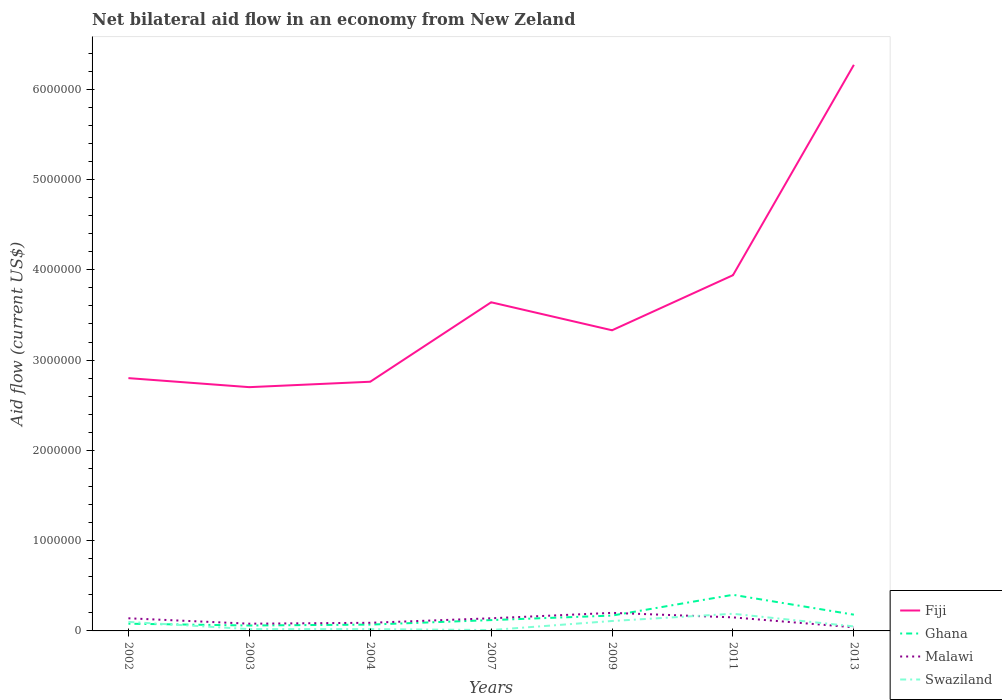Does the line corresponding to Fiji intersect with the line corresponding to Malawi?
Keep it short and to the point. No. Is the number of lines equal to the number of legend labels?
Make the answer very short. Yes. What is the total net bilateral aid flow in Malawi in the graph?
Provide a short and direct response. 0. What is the difference between the highest and the second highest net bilateral aid flow in Swaziland?
Ensure brevity in your answer.  1.80e+05. What is the difference between the highest and the lowest net bilateral aid flow in Swaziland?
Make the answer very short. 3. What is the difference between two consecutive major ticks on the Y-axis?
Give a very brief answer. 1.00e+06. Does the graph contain any zero values?
Your answer should be very brief. No. How many legend labels are there?
Provide a short and direct response. 4. How are the legend labels stacked?
Ensure brevity in your answer.  Vertical. What is the title of the graph?
Your answer should be compact. Net bilateral aid flow in an economy from New Zeland. Does "Caribbean small states" appear as one of the legend labels in the graph?
Provide a short and direct response. No. What is the label or title of the Y-axis?
Give a very brief answer. Aid flow (current US$). What is the Aid flow (current US$) in Fiji in 2002?
Provide a short and direct response. 2.80e+06. What is the Aid flow (current US$) in Ghana in 2002?
Your answer should be very brief. 8.00e+04. What is the Aid flow (current US$) in Malawi in 2002?
Give a very brief answer. 1.40e+05. What is the Aid flow (current US$) of Swaziland in 2002?
Give a very brief answer. 1.00e+05. What is the Aid flow (current US$) in Fiji in 2003?
Provide a succinct answer. 2.70e+06. What is the Aid flow (current US$) of Malawi in 2003?
Your response must be concise. 8.00e+04. What is the Aid flow (current US$) in Swaziland in 2003?
Give a very brief answer. 2.00e+04. What is the Aid flow (current US$) in Fiji in 2004?
Offer a very short reply. 2.76e+06. What is the Aid flow (current US$) in Ghana in 2004?
Keep it short and to the point. 7.00e+04. What is the Aid flow (current US$) of Fiji in 2007?
Your answer should be compact. 3.64e+06. What is the Aid flow (current US$) of Ghana in 2007?
Your answer should be compact. 1.20e+05. What is the Aid flow (current US$) in Malawi in 2007?
Offer a terse response. 1.40e+05. What is the Aid flow (current US$) in Fiji in 2009?
Ensure brevity in your answer.  3.33e+06. What is the Aid flow (current US$) of Swaziland in 2009?
Ensure brevity in your answer.  1.10e+05. What is the Aid flow (current US$) in Fiji in 2011?
Give a very brief answer. 3.94e+06. What is the Aid flow (current US$) of Swaziland in 2011?
Offer a terse response. 1.90e+05. What is the Aid flow (current US$) in Fiji in 2013?
Offer a terse response. 6.27e+06. What is the Aid flow (current US$) in Malawi in 2013?
Your response must be concise. 4.00e+04. What is the Aid flow (current US$) of Swaziland in 2013?
Make the answer very short. 5.00e+04. Across all years, what is the maximum Aid flow (current US$) of Fiji?
Provide a succinct answer. 6.27e+06. Across all years, what is the maximum Aid flow (current US$) in Ghana?
Give a very brief answer. 4.00e+05. Across all years, what is the maximum Aid flow (current US$) in Malawi?
Offer a very short reply. 2.00e+05. Across all years, what is the maximum Aid flow (current US$) of Swaziland?
Make the answer very short. 1.90e+05. Across all years, what is the minimum Aid flow (current US$) in Fiji?
Make the answer very short. 2.70e+06. Across all years, what is the minimum Aid flow (current US$) of Malawi?
Provide a short and direct response. 4.00e+04. Across all years, what is the minimum Aid flow (current US$) in Swaziland?
Your answer should be compact. 10000. What is the total Aid flow (current US$) in Fiji in the graph?
Provide a short and direct response. 2.54e+07. What is the total Aid flow (current US$) of Ghana in the graph?
Keep it short and to the point. 1.08e+06. What is the total Aid flow (current US$) of Malawi in the graph?
Ensure brevity in your answer.  8.40e+05. What is the difference between the Aid flow (current US$) of Fiji in 2002 and that in 2003?
Ensure brevity in your answer.  1.00e+05. What is the difference between the Aid flow (current US$) of Malawi in 2002 and that in 2003?
Give a very brief answer. 6.00e+04. What is the difference between the Aid flow (current US$) in Fiji in 2002 and that in 2004?
Keep it short and to the point. 4.00e+04. What is the difference between the Aid flow (current US$) in Ghana in 2002 and that in 2004?
Keep it short and to the point. 10000. What is the difference between the Aid flow (current US$) of Swaziland in 2002 and that in 2004?
Provide a short and direct response. 8.00e+04. What is the difference between the Aid flow (current US$) in Fiji in 2002 and that in 2007?
Give a very brief answer. -8.40e+05. What is the difference between the Aid flow (current US$) in Malawi in 2002 and that in 2007?
Ensure brevity in your answer.  0. What is the difference between the Aid flow (current US$) of Fiji in 2002 and that in 2009?
Provide a short and direct response. -5.30e+05. What is the difference between the Aid flow (current US$) in Ghana in 2002 and that in 2009?
Provide a short and direct response. -9.00e+04. What is the difference between the Aid flow (current US$) in Malawi in 2002 and that in 2009?
Provide a succinct answer. -6.00e+04. What is the difference between the Aid flow (current US$) of Swaziland in 2002 and that in 2009?
Offer a terse response. -10000. What is the difference between the Aid flow (current US$) of Fiji in 2002 and that in 2011?
Offer a terse response. -1.14e+06. What is the difference between the Aid flow (current US$) of Ghana in 2002 and that in 2011?
Give a very brief answer. -3.20e+05. What is the difference between the Aid flow (current US$) of Malawi in 2002 and that in 2011?
Your response must be concise. -10000. What is the difference between the Aid flow (current US$) in Swaziland in 2002 and that in 2011?
Your answer should be compact. -9.00e+04. What is the difference between the Aid flow (current US$) in Fiji in 2002 and that in 2013?
Your response must be concise. -3.47e+06. What is the difference between the Aid flow (current US$) of Malawi in 2002 and that in 2013?
Provide a short and direct response. 1.00e+05. What is the difference between the Aid flow (current US$) of Swaziland in 2002 and that in 2013?
Your response must be concise. 5.00e+04. What is the difference between the Aid flow (current US$) of Ghana in 2003 and that in 2004?
Give a very brief answer. -10000. What is the difference between the Aid flow (current US$) in Malawi in 2003 and that in 2004?
Offer a terse response. -10000. What is the difference between the Aid flow (current US$) of Fiji in 2003 and that in 2007?
Give a very brief answer. -9.40e+05. What is the difference between the Aid flow (current US$) in Malawi in 2003 and that in 2007?
Make the answer very short. -6.00e+04. What is the difference between the Aid flow (current US$) of Fiji in 2003 and that in 2009?
Your response must be concise. -6.30e+05. What is the difference between the Aid flow (current US$) of Malawi in 2003 and that in 2009?
Your answer should be very brief. -1.20e+05. What is the difference between the Aid flow (current US$) of Fiji in 2003 and that in 2011?
Offer a terse response. -1.24e+06. What is the difference between the Aid flow (current US$) of Swaziland in 2003 and that in 2011?
Provide a short and direct response. -1.70e+05. What is the difference between the Aid flow (current US$) of Fiji in 2003 and that in 2013?
Your answer should be compact. -3.57e+06. What is the difference between the Aid flow (current US$) in Fiji in 2004 and that in 2007?
Offer a very short reply. -8.80e+05. What is the difference between the Aid flow (current US$) of Ghana in 2004 and that in 2007?
Provide a short and direct response. -5.00e+04. What is the difference between the Aid flow (current US$) of Malawi in 2004 and that in 2007?
Make the answer very short. -5.00e+04. What is the difference between the Aid flow (current US$) in Swaziland in 2004 and that in 2007?
Make the answer very short. 10000. What is the difference between the Aid flow (current US$) of Fiji in 2004 and that in 2009?
Your answer should be very brief. -5.70e+05. What is the difference between the Aid flow (current US$) in Ghana in 2004 and that in 2009?
Offer a terse response. -1.00e+05. What is the difference between the Aid flow (current US$) of Swaziland in 2004 and that in 2009?
Offer a terse response. -9.00e+04. What is the difference between the Aid flow (current US$) in Fiji in 2004 and that in 2011?
Provide a succinct answer. -1.18e+06. What is the difference between the Aid flow (current US$) in Ghana in 2004 and that in 2011?
Provide a short and direct response. -3.30e+05. What is the difference between the Aid flow (current US$) of Swaziland in 2004 and that in 2011?
Provide a succinct answer. -1.70e+05. What is the difference between the Aid flow (current US$) of Fiji in 2004 and that in 2013?
Offer a terse response. -3.51e+06. What is the difference between the Aid flow (current US$) of Ghana in 2004 and that in 2013?
Provide a succinct answer. -1.10e+05. What is the difference between the Aid flow (current US$) of Fiji in 2007 and that in 2009?
Make the answer very short. 3.10e+05. What is the difference between the Aid flow (current US$) in Malawi in 2007 and that in 2009?
Your answer should be compact. -6.00e+04. What is the difference between the Aid flow (current US$) in Fiji in 2007 and that in 2011?
Make the answer very short. -3.00e+05. What is the difference between the Aid flow (current US$) in Ghana in 2007 and that in 2011?
Offer a terse response. -2.80e+05. What is the difference between the Aid flow (current US$) of Fiji in 2007 and that in 2013?
Your answer should be compact. -2.63e+06. What is the difference between the Aid flow (current US$) in Swaziland in 2007 and that in 2013?
Provide a short and direct response. -4.00e+04. What is the difference between the Aid flow (current US$) of Fiji in 2009 and that in 2011?
Offer a very short reply. -6.10e+05. What is the difference between the Aid flow (current US$) in Malawi in 2009 and that in 2011?
Ensure brevity in your answer.  5.00e+04. What is the difference between the Aid flow (current US$) in Swaziland in 2009 and that in 2011?
Your response must be concise. -8.00e+04. What is the difference between the Aid flow (current US$) of Fiji in 2009 and that in 2013?
Keep it short and to the point. -2.94e+06. What is the difference between the Aid flow (current US$) of Fiji in 2011 and that in 2013?
Give a very brief answer. -2.33e+06. What is the difference between the Aid flow (current US$) of Malawi in 2011 and that in 2013?
Your response must be concise. 1.10e+05. What is the difference between the Aid flow (current US$) of Swaziland in 2011 and that in 2013?
Your response must be concise. 1.40e+05. What is the difference between the Aid flow (current US$) of Fiji in 2002 and the Aid flow (current US$) of Ghana in 2003?
Ensure brevity in your answer.  2.74e+06. What is the difference between the Aid flow (current US$) in Fiji in 2002 and the Aid flow (current US$) in Malawi in 2003?
Provide a short and direct response. 2.72e+06. What is the difference between the Aid flow (current US$) in Fiji in 2002 and the Aid flow (current US$) in Swaziland in 2003?
Provide a succinct answer. 2.78e+06. What is the difference between the Aid flow (current US$) in Ghana in 2002 and the Aid flow (current US$) in Swaziland in 2003?
Keep it short and to the point. 6.00e+04. What is the difference between the Aid flow (current US$) in Malawi in 2002 and the Aid flow (current US$) in Swaziland in 2003?
Your response must be concise. 1.20e+05. What is the difference between the Aid flow (current US$) of Fiji in 2002 and the Aid flow (current US$) of Ghana in 2004?
Give a very brief answer. 2.73e+06. What is the difference between the Aid flow (current US$) of Fiji in 2002 and the Aid flow (current US$) of Malawi in 2004?
Offer a terse response. 2.71e+06. What is the difference between the Aid flow (current US$) in Fiji in 2002 and the Aid flow (current US$) in Swaziland in 2004?
Give a very brief answer. 2.78e+06. What is the difference between the Aid flow (current US$) in Ghana in 2002 and the Aid flow (current US$) in Malawi in 2004?
Your answer should be compact. -10000. What is the difference between the Aid flow (current US$) of Ghana in 2002 and the Aid flow (current US$) of Swaziland in 2004?
Offer a terse response. 6.00e+04. What is the difference between the Aid flow (current US$) in Malawi in 2002 and the Aid flow (current US$) in Swaziland in 2004?
Offer a very short reply. 1.20e+05. What is the difference between the Aid flow (current US$) in Fiji in 2002 and the Aid flow (current US$) in Ghana in 2007?
Offer a very short reply. 2.68e+06. What is the difference between the Aid flow (current US$) of Fiji in 2002 and the Aid flow (current US$) of Malawi in 2007?
Offer a terse response. 2.66e+06. What is the difference between the Aid flow (current US$) in Fiji in 2002 and the Aid flow (current US$) in Swaziland in 2007?
Provide a succinct answer. 2.79e+06. What is the difference between the Aid flow (current US$) of Ghana in 2002 and the Aid flow (current US$) of Malawi in 2007?
Your response must be concise. -6.00e+04. What is the difference between the Aid flow (current US$) in Fiji in 2002 and the Aid flow (current US$) in Ghana in 2009?
Keep it short and to the point. 2.63e+06. What is the difference between the Aid flow (current US$) of Fiji in 2002 and the Aid flow (current US$) of Malawi in 2009?
Give a very brief answer. 2.60e+06. What is the difference between the Aid flow (current US$) in Fiji in 2002 and the Aid flow (current US$) in Swaziland in 2009?
Offer a terse response. 2.69e+06. What is the difference between the Aid flow (current US$) of Fiji in 2002 and the Aid flow (current US$) of Ghana in 2011?
Your answer should be compact. 2.40e+06. What is the difference between the Aid flow (current US$) in Fiji in 2002 and the Aid flow (current US$) in Malawi in 2011?
Offer a very short reply. 2.65e+06. What is the difference between the Aid flow (current US$) of Fiji in 2002 and the Aid flow (current US$) of Swaziland in 2011?
Offer a terse response. 2.61e+06. What is the difference between the Aid flow (current US$) of Fiji in 2002 and the Aid flow (current US$) of Ghana in 2013?
Ensure brevity in your answer.  2.62e+06. What is the difference between the Aid flow (current US$) in Fiji in 2002 and the Aid flow (current US$) in Malawi in 2013?
Offer a terse response. 2.76e+06. What is the difference between the Aid flow (current US$) of Fiji in 2002 and the Aid flow (current US$) of Swaziland in 2013?
Ensure brevity in your answer.  2.75e+06. What is the difference between the Aid flow (current US$) of Ghana in 2002 and the Aid flow (current US$) of Malawi in 2013?
Your answer should be compact. 4.00e+04. What is the difference between the Aid flow (current US$) of Fiji in 2003 and the Aid flow (current US$) of Ghana in 2004?
Your answer should be very brief. 2.63e+06. What is the difference between the Aid flow (current US$) of Fiji in 2003 and the Aid flow (current US$) of Malawi in 2004?
Make the answer very short. 2.61e+06. What is the difference between the Aid flow (current US$) of Fiji in 2003 and the Aid flow (current US$) of Swaziland in 2004?
Give a very brief answer. 2.68e+06. What is the difference between the Aid flow (current US$) of Ghana in 2003 and the Aid flow (current US$) of Malawi in 2004?
Give a very brief answer. -3.00e+04. What is the difference between the Aid flow (current US$) in Malawi in 2003 and the Aid flow (current US$) in Swaziland in 2004?
Your answer should be very brief. 6.00e+04. What is the difference between the Aid flow (current US$) in Fiji in 2003 and the Aid flow (current US$) in Ghana in 2007?
Provide a short and direct response. 2.58e+06. What is the difference between the Aid flow (current US$) in Fiji in 2003 and the Aid flow (current US$) in Malawi in 2007?
Make the answer very short. 2.56e+06. What is the difference between the Aid flow (current US$) of Fiji in 2003 and the Aid flow (current US$) of Swaziland in 2007?
Keep it short and to the point. 2.69e+06. What is the difference between the Aid flow (current US$) in Ghana in 2003 and the Aid flow (current US$) in Malawi in 2007?
Your answer should be very brief. -8.00e+04. What is the difference between the Aid flow (current US$) of Ghana in 2003 and the Aid flow (current US$) of Swaziland in 2007?
Your answer should be compact. 5.00e+04. What is the difference between the Aid flow (current US$) in Fiji in 2003 and the Aid flow (current US$) in Ghana in 2009?
Provide a succinct answer. 2.53e+06. What is the difference between the Aid flow (current US$) of Fiji in 2003 and the Aid flow (current US$) of Malawi in 2009?
Offer a very short reply. 2.50e+06. What is the difference between the Aid flow (current US$) in Fiji in 2003 and the Aid flow (current US$) in Swaziland in 2009?
Offer a terse response. 2.59e+06. What is the difference between the Aid flow (current US$) in Ghana in 2003 and the Aid flow (current US$) in Malawi in 2009?
Make the answer very short. -1.40e+05. What is the difference between the Aid flow (current US$) in Ghana in 2003 and the Aid flow (current US$) in Swaziland in 2009?
Give a very brief answer. -5.00e+04. What is the difference between the Aid flow (current US$) in Malawi in 2003 and the Aid flow (current US$) in Swaziland in 2009?
Give a very brief answer. -3.00e+04. What is the difference between the Aid flow (current US$) in Fiji in 2003 and the Aid flow (current US$) in Ghana in 2011?
Your response must be concise. 2.30e+06. What is the difference between the Aid flow (current US$) of Fiji in 2003 and the Aid flow (current US$) of Malawi in 2011?
Provide a succinct answer. 2.55e+06. What is the difference between the Aid flow (current US$) in Fiji in 2003 and the Aid flow (current US$) in Swaziland in 2011?
Ensure brevity in your answer.  2.51e+06. What is the difference between the Aid flow (current US$) in Ghana in 2003 and the Aid flow (current US$) in Malawi in 2011?
Give a very brief answer. -9.00e+04. What is the difference between the Aid flow (current US$) of Fiji in 2003 and the Aid flow (current US$) of Ghana in 2013?
Give a very brief answer. 2.52e+06. What is the difference between the Aid flow (current US$) in Fiji in 2003 and the Aid flow (current US$) in Malawi in 2013?
Ensure brevity in your answer.  2.66e+06. What is the difference between the Aid flow (current US$) in Fiji in 2003 and the Aid flow (current US$) in Swaziland in 2013?
Your answer should be very brief. 2.65e+06. What is the difference between the Aid flow (current US$) of Malawi in 2003 and the Aid flow (current US$) of Swaziland in 2013?
Provide a short and direct response. 3.00e+04. What is the difference between the Aid flow (current US$) of Fiji in 2004 and the Aid flow (current US$) of Ghana in 2007?
Your answer should be compact. 2.64e+06. What is the difference between the Aid flow (current US$) in Fiji in 2004 and the Aid flow (current US$) in Malawi in 2007?
Provide a short and direct response. 2.62e+06. What is the difference between the Aid flow (current US$) of Fiji in 2004 and the Aid flow (current US$) of Swaziland in 2007?
Your answer should be very brief. 2.75e+06. What is the difference between the Aid flow (current US$) in Ghana in 2004 and the Aid flow (current US$) in Swaziland in 2007?
Give a very brief answer. 6.00e+04. What is the difference between the Aid flow (current US$) in Fiji in 2004 and the Aid flow (current US$) in Ghana in 2009?
Keep it short and to the point. 2.59e+06. What is the difference between the Aid flow (current US$) of Fiji in 2004 and the Aid flow (current US$) of Malawi in 2009?
Your answer should be very brief. 2.56e+06. What is the difference between the Aid flow (current US$) in Fiji in 2004 and the Aid flow (current US$) in Swaziland in 2009?
Keep it short and to the point. 2.65e+06. What is the difference between the Aid flow (current US$) in Ghana in 2004 and the Aid flow (current US$) in Swaziland in 2009?
Ensure brevity in your answer.  -4.00e+04. What is the difference between the Aid flow (current US$) in Malawi in 2004 and the Aid flow (current US$) in Swaziland in 2009?
Your response must be concise. -2.00e+04. What is the difference between the Aid flow (current US$) of Fiji in 2004 and the Aid flow (current US$) of Ghana in 2011?
Keep it short and to the point. 2.36e+06. What is the difference between the Aid flow (current US$) in Fiji in 2004 and the Aid flow (current US$) in Malawi in 2011?
Make the answer very short. 2.61e+06. What is the difference between the Aid flow (current US$) of Fiji in 2004 and the Aid flow (current US$) of Swaziland in 2011?
Provide a short and direct response. 2.57e+06. What is the difference between the Aid flow (current US$) of Ghana in 2004 and the Aid flow (current US$) of Malawi in 2011?
Provide a succinct answer. -8.00e+04. What is the difference between the Aid flow (current US$) of Fiji in 2004 and the Aid flow (current US$) of Ghana in 2013?
Provide a short and direct response. 2.58e+06. What is the difference between the Aid flow (current US$) of Fiji in 2004 and the Aid flow (current US$) of Malawi in 2013?
Your answer should be very brief. 2.72e+06. What is the difference between the Aid flow (current US$) in Fiji in 2004 and the Aid flow (current US$) in Swaziland in 2013?
Your answer should be compact. 2.71e+06. What is the difference between the Aid flow (current US$) in Ghana in 2004 and the Aid flow (current US$) in Swaziland in 2013?
Ensure brevity in your answer.  2.00e+04. What is the difference between the Aid flow (current US$) in Fiji in 2007 and the Aid flow (current US$) in Ghana in 2009?
Provide a short and direct response. 3.47e+06. What is the difference between the Aid flow (current US$) of Fiji in 2007 and the Aid flow (current US$) of Malawi in 2009?
Provide a short and direct response. 3.44e+06. What is the difference between the Aid flow (current US$) in Fiji in 2007 and the Aid flow (current US$) in Swaziland in 2009?
Your answer should be compact. 3.53e+06. What is the difference between the Aid flow (current US$) of Ghana in 2007 and the Aid flow (current US$) of Swaziland in 2009?
Your response must be concise. 10000. What is the difference between the Aid flow (current US$) of Fiji in 2007 and the Aid flow (current US$) of Ghana in 2011?
Your response must be concise. 3.24e+06. What is the difference between the Aid flow (current US$) of Fiji in 2007 and the Aid flow (current US$) of Malawi in 2011?
Make the answer very short. 3.49e+06. What is the difference between the Aid flow (current US$) of Fiji in 2007 and the Aid flow (current US$) of Swaziland in 2011?
Make the answer very short. 3.45e+06. What is the difference between the Aid flow (current US$) in Ghana in 2007 and the Aid flow (current US$) in Malawi in 2011?
Keep it short and to the point. -3.00e+04. What is the difference between the Aid flow (current US$) of Fiji in 2007 and the Aid flow (current US$) of Ghana in 2013?
Ensure brevity in your answer.  3.46e+06. What is the difference between the Aid flow (current US$) in Fiji in 2007 and the Aid flow (current US$) in Malawi in 2013?
Your response must be concise. 3.60e+06. What is the difference between the Aid flow (current US$) in Fiji in 2007 and the Aid flow (current US$) in Swaziland in 2013?
Offer a very short reply. 3.59e+06. What is the difference between the Aid flow (current US$) in Malawi in 2007 and the Aid flow (current US$) in Swaziland in 2013?
Your response must be concise. 9.00e+04. What is the difference between the Aid flow (current US$) of Fiji in 2009 and the Aid flow (current US$) of Ghana in 2011?
Your answer should be very brief. 2.93e+06. What is the difference between the Aid flow (current US$) in Fiji in 2009 and the Aid flow (current US$) in Malawi in 2011?
Your response must be concise. 3.18e+06. What is the difference between the Aid flow (current US$) in Fiji in 2009 and the Aid flow (current US$) in Swaziland in 2011?
Your answer should be compact. 3.14e+06. What is the difference between the Aid flow (current US$) of Malawi in 2009 and the Aid flow (current US$) of Swaziland in 2011?
Offer a terse response. 10000. What is the difference between the Aid flow (current US$) of Fiji in 2009 and the Aid flow (current US$) of Ghana in 2013?
Your response must be concise. 3.15e+06. What is the difference between the Aid flow (current US$) of Fiji in 2009 and the Aid flow (current US$) of Malawi in 2013?
Your response must be concise. 3.29e+06. What is the difference between the Aid flow (current US$) in Fiji in 2009 and the Aid flow (current US$) in Swaziland in 2013?
Provide a succinct answer. 3.28e+06. What is the difference between the Aid flow (current US$) of Ghana in 2009 and the Aid flow (current US$) of Malawi in 2013?
Your answer should be compact. 1.30e+05. What is the difference between the Aid flow (current US$) in Ghana in 2009 and the Aid flow (current US$) in Swaziland in 2013?
Provide a short and direct response. 1.20e+05. What is the difference between the Aid flow (current US$) of Fiji in 2011 and the Aid flow (current US$) of Ghana in 2013?
Ensure brevity in your answer.  3.76e+06. What is the difference between the Aid flow (current US$) in Fiji in 2011 and the Aid flow (current US$) in Malawi in 2013?
Ensure brevity in your answer.  3.90e+06. What is the difference between the Aid flow (current US$) of Fiji in 2011 and the Aid flow (current US$) of Swaziland in 2013?
Provide a short and direct response. 3.89e+06. What is the difference between the Aid flow (current US$) in Ghana in 2011 and the Aid flow (current US$) in Malawi in 2013?
Offer a terse response. 3.60e+05. What is the difference between the Aid flow (current US$) in Ghana in 2011 and the Aid flow (current US$) in Swaziland in 2013?
Provide a short and direct response. 3.50e+05. What is the average Aid flow (current US$) in Fiji per year?
Your response must be concise. 3.63e+06. What is the average Aid flow (current US$) of Ghana per year?
Make the answer very short. 1.54e+05. What is the average Aid flow (current US$) of Swaziland per year?
Your answer should be compact. 7.14e+04. In the year 2002, what is the difference between the Aid flow (current US$) of Fiji and Aid flow (current US$) of Ghana?
Your answer should be compact. 2.72e+06. In the year 2002, what is the difference between the Aid flow (current US$) in Fiji and Aid flow (current US$) in Malawi?
Provide a short and direct response. 2.66e+06. In the year 2002, what is the difference between the Aid flow (current US$) of Fiji and Aid flow (current US$) of Swaziland?
Provide a short and direct response. 2.70e+06. In the year 2002, what is the difference between the Aid flow (current US$) in Ghana and Aid flow (current US$) in Swaziland?
Your response must be concise. -2.00e+04. In the year 2003, what is the difference between the Aid flow (current US$) in Fiji and Aid flow (current US$) in Ghana?
Your answer should be very brief. 2.64e+06. In the year 2003, what is the difference between the Aid flow (current US$) in Fiji and Aid flow (current US$) in Malawi?
Provide a short and direct response. 2.62e+06. In the year 2003, what is the difference between the Aid flow (current US$) of Fiji and Aid flow (current US$) of Swaziland?
Offer a terse response. 2.68e+06. In the year 2003, what is the difference between the Aid flow (current US$) in Ghana and Aid flow (current US$) in Malawi?
Provide a succinct answer. -2.00e+04. In the year 2003, what is the difference between the Aid flow (current US$) in Ghana and Aid flow (current US$) in Swaziland?
Make the answer very short. 4.00e+04. In the year 2003, what is the difference between the Aid flow (current US$) in Malawi and Aid flow (current US$) in Swaziland?
Your response must be concise. 6.00e+04. In the year 2004, what is the difference between the Aid flow (current US$) in Fiji and Aid flow (current US$) in Ghana?
Your answer should be compact. 2.69e+06. In the year 2004, what is the difference between the Aid flow (current US$) in Fiji and Aid flow (current US$) in Malawi?
Make the answer very short. 2.67e+06. In the year 2004, what is the difference between the Aid flow (current US$) of Fiji and Aid flow (current US$) of Swaziland?
Make the answer very short. 2.74e+06. In the year 2004, what is the difference between the Aid flow (current US$) of Malawi and Aid flow (current US$) of Swaziland?
Your answer should be very brief. 7.00e+04. In the year 2007, what is the difference between the Aid flow (current US$) of Fiji and Aid flow (current US$) of Ghana?
Your answer should be very brief. 3.52e+06. In the year 2007, what is the difference between the Aid flow (current US$) in Fiji and Aid flow (current US$) in Malawi?
Keep it short and to the point. 3.50e+06. In the year 2007, what is the difference between the Aid flow (current US$) of Fiji and Aid flow (current US$) of Swaziland?
Make the answer very short. 3.63e+06. In the year 2007, what is the difference between the Aid flow (current US$) in Ghana and Aid flow (current US$) in Swaziland?
Ensure brevity in your answer.  1.10e+05. In the year 2009, what is the difference between the Aid flow (current US$) of Fiji and Aid flow (current US$) of Ghana?
Your answer should be very brief. 3.16e+06. In the year 2009, what is the difference between the Aid flow (current US$) of Fiji and Aid flow (current US$) of Malawi?
Provide a succinct answer. 3.13e+06. In the year 2009, what is the difference between the Aid flow (current US$) of Fiji and Aid flow (current US$) of Swaziland?
Ensure brevity in your answer.  3.22e+06. In the year 2009, what is the difference between the Aid flow (current US$) of Ghana and Aid flow (current US$) of Malawi?
Make the answer very short. -3.00e+04. In the year 2011, what is the difference between the Aid flow (current US$) of Fiji and Aid flow (current US$) of Ghana?
Make the answer very short. 3.54e+06. In the year 2011, what is the difference between the Aid flow (current US$) in Fiji and Aid flow (current US$) in Malawi?
Ensure brevity in your answer.  3.79e+06. In the year 2011, what is the difference between the Aid flow (current US$) in Fiji and Aid flow (current US$) in Swaziland?
Give a very brief answer. 3.75e+06. In the year 2013, what is the difference between the Aid flow (current US$) in Fiji and Aid flow (current US$) in Ghana?
Provide a short and direct response. 6.09e+06. In the year 2013, what is the difference between the Aid flow (current US$) in Fiji and Aid flow (current US$) in Malawi?
Provide a succinct answer. 6.23e+06. In the year 2013, what is the difference between the Aid flow (current US$) in Fiji and Aid flow (current US$) in Swaziland?
Provide a succinct answer. 6.22e+06. What is the ratio of the Aid flow (current US$) of Fiji in 2002 to that in 2003?
Your answer should be compact. 1.04. What is the ratio of the Aid flow (current US$) of Ghana in 2002 to that in 2003?
Make the answer very short. 1.33. What is the ratio of the Aid flow (current US$) in Swaziland in 2002 to that in 2003?
Make the answer very short. 5. What is the ratio of the Aid flow (current US$) in Fiji in 2002 to that in 2004?
Your answer should be compact. 1.01. What is the ratio of the Aid flow (current US$) of Ghana in 2002 to that in 2004?
Your response must be concise. 1.14. What is the ratio of the Aid flow (current US$) of Malawi in 2002 to that in 2004?
Your answer should be compact. 1.56. What is the ratio of the Aid flow (current US$) of Fiji in 2002 to that in 2007?
Offer a very short reply. 0.77. What is the ratio of the Aid flow (current US$) of Ghana in 2002 to that in 2007?
Make the answer very short. 0.67. What is the ratio of the Aid flow (current US$) in Malawi in 2002 to that in 2007?
Keep it short and to the point. 1. What is the ratio of the Aid flow (current US$) of Fiji in 2002 to that in 2009?
Your response must be concise. 0.84. What is the ratio of the Aid flow (current US$) in Ghana in 2002 to that in 2009?
Provide a short and direct response. 0.47. What is the ratio of the Aid flow (current US$) of Fiji in 2002 to that in 2011?
Keep it short and to the point. 0.71. What is the ratio of the Aid flow (current US$) in Malawi in 2002 to that in 2011?
Your answer should be compact. 0.93. What is the ratio of the Aid flow (current US$) in Swaziland in 2002 to that in 2011?
Keep it short and to the point. 0.53. What is the ratio of the Aid flow (current US$) of Fiji in 2002 to that in 2013?
Give a very brief answer. 0.45. What is the ratio of the Aid flow (current US$) in Ghana in 2002 to that in 2013?
Keep it short and to the point. 0.44. What is the ratio of the Aid flow (current US$) in Malawi in 2002 to that in 2013?
Your answer should be compact. 3.5. What is the ratio of the Aid flow (current US$) in Swaziland in 2002 to that in 2013?
Provide a succinct answer. 2. What is the ratio of the Aid flow (current US$) in Fiji in 2003 to that in 2004?
Your answer should be compact. 0.98. What is the ratio of the Aid flow (current US$) of Malawi in 2003 to that in 2004?
Your answer should be compact. 0.89. What is the ratio of the Aid flow (current US$) of Fiji in 2003 to that in 2007?
Offer a very short reply. 0.74. What is the ratio of the Aid flow (current US$) in Ghana in 2003 to that in 2007?
Your answer should be very brief. 0.5. What is the ratio of the Aid flow (current US$) in Malawi in 2003 to that in 2007?
Your response must be concise. 0.57. What is the ratio of the Aid flow (current US$) in Swaziland in 2003 to that in 2007?
Provide a succinct answer. 2. What is the ratio of the Aid flow (current US$) in Fiji in 2003 to that in 2009?
Keep it short and to the point. 0.81. What is the ratio of the Aid flow (current US$) in Ghana in 2003 to that in 2009?
Your answer should be very brief. 0.35. What is the ratio of the Aid flow (current US$) in Swaziland in 2003 to that in 2009?
Give a very brief answer. 0.18. What is the ratio of the Aid flow (current US$) in Fiji in 2003 to that in 2011?
Give a very brief answer. 0.69. What is the ratio of the Aid flow (current US$) of Malawi in 2003 to that in 2011?
Offer a very short reply. 0.53. What is the ratio of the Aid flow (current US$) in Swaziland in 2003 to that in 2011?
Offer a very short reply. 0.11. What is the ratio of the Aid flow (current US$) in Fiji in 2003 to that in 2013?
Give a very brief answer. 0.43. What is the ratio of the Aid flow (current US$) in Malawi in 2003 to that in 2013?
Keep it short and to the point. 2. What is the ratio of the Aid flow (current US$) in Swaziland in 2003 to that in 2013?
Your response must be concise. 0.4. What is the ratio of the Aid flow (current US$) of Fiji in 2004 to that in 2007?
Your response must be concise. 0.76. What is the ratio of the Aid flow (current US$) of Ghana in 2004 to that in 2007?
Offer a very short reply. 0.58. What is the ratio of the Aid flow (current US$) in Malawi in 2004 to that in 2007?
Give a very brief answer. 0.64. What is the ratio of the Aid flow (current US$) in Fiji in 2004 to that in 2009?
Offer a terse response. 0.83. What is the ratio of the Aid flow (current US$) in Ghana in 2004 to that in 2009?
Offer a terse response. 0.41. What is the ratio of the Aid flow (current US$) in Malawi in 2004 to that in 2009?
Your response must be concise. 0.45. What is the ratio of the Aid flow (current US$) of Swaziland in 2004 to that in 2009?
Offer a very short reply. 0.18. What is the ratio of the Aid flow (current US$) of Fiji in 2004 to that in 2011?
Your answer should be compact. 0.7. What is the ratio of the Aid flow (current US$) in Ghana in 2004 to that in 2011?
Make the answer very short. 0.17. What is the ratio of the Aid flow (current US$) in Swaziland in 2004 to that in 2011?
Ensure brevity in your answer.  0.11. What is the ratio of the Aid flow (current US$) of Fiji in 2004 to that in 2013?
Keep it short and to the point. 0.44. What is the ratio of the Aid flow (current US$) in Ghana in 2004 to that in 2013?
Offer a terse response. 0.39. What is the ratio of the Aid flow (current US$) of Malawi in 2004 to that in 2013?
Offer a very short reply. 2.25. What is the ratio of the Aid flow (current US$) in Swaziland in 2004 to that in 2013?
Offer a terse response. 0.4. What is the ratio of the Aid flow (current US$) of Fiji in 2007 to that in 2009?
Your response must be concise. 1.09. What is the ratio of the Aid flow (current US$) of Ghana in 2007 to that in 2009?
Your answer should be very brief. 0.71. What is the ratio of the Aid flow (current US$) in Swaziland in 2007 to that in 2009?
Ensure brevity in your answer.  0.09. What is the ratio of the Aid flow (current US$) of Fiji in 2007 to that in 2011?
Keep it short and to the point. 0.92. What is the ratio of the Aid flow (current US$) of Malawi in 2007 to that in 2011?
Provide a short and direct response. 0.93. What is the ratio of the Aid flow (current US$) in Swaziland in 2007 to that in 2011?
Your answer should be compact. 0.05. What is the ratio of the Aid flow (current US$) in Fiji in 2007 to that in 2013?
Give a very brief answer. 0.58. What is the ratio of the Aid flow (current US$) in Ghana in 2007 to that in 2013?
Your answer should be compact. 0.67. What is the ratio of the Aid flow (current US$) in Swaziland in 2007 to that in 2013?
Give a very brief answer. 0.2. What is the ratio of the Aid flow (current US$) in Fiji in 2009 to that in 2011?
Provide a succinct answer. 0.85. What is the ratio of the Aid flow (current US$) in Ghana in 2009 to that in 2011?
Ensure brevity in your answer.  0.42. What is the ratio of the Aid flow (current US$) of Swaziland in 2009 to that in 2011?
Your answer should be compact. 0.58. What is the ratio of the Aid flow (current US$) in Fiji in 2009 to that in 2013?
Offer a very short reply. 0.53. What is the ratio of the Aid flow (current US$) of Ghana in 2009 to that in 2013?
Make the answer very short. 0.94. What is the ratio of the Aid flow (current US$) in Malawi in 2009 to that in 2013?
Your answer should be very brief. 5. What is the ratio of the Aid flow (current US$) of Fiji in 2011 to that in 2013?
Ensure brevity in your answer.  0.63. What is the ratio of the Aid flow (current US$) in Ghana in 2011 to that in 2013?
Make the answer very short. 2.22. What is the ratio of the Aid flow (current US$) of Malawi in 2011 to that in 2013?
Offer a very short reply. 3.75. What is the difference between the highest and the second highest Aid flow (current US$) in Fiji?
Ensure brevity in your answer.  2.33e+06. What is the difference between the highest and the second highest Aid flow (current US$) in Malawi?
Your answer should be very brief. 5.00e+04. What is the difference between the highest and the second highest Aid flow (current US$) in Swaziland?
Offer a very short reply. 8.00e+04. What is the difference between the highest and the lowest Aid flow (current US$) of Fiji?
Your response must be concise. 3.57e+06. What is the difference between the highest and the lowest Aid flow (current US$) of Malawi?
Make the answer very short. 1.60e+05. What is the difference between the highest and the lowest Aid flow (current US$) in Swaziland?
Give a very brief answer. 1.80e+05. 